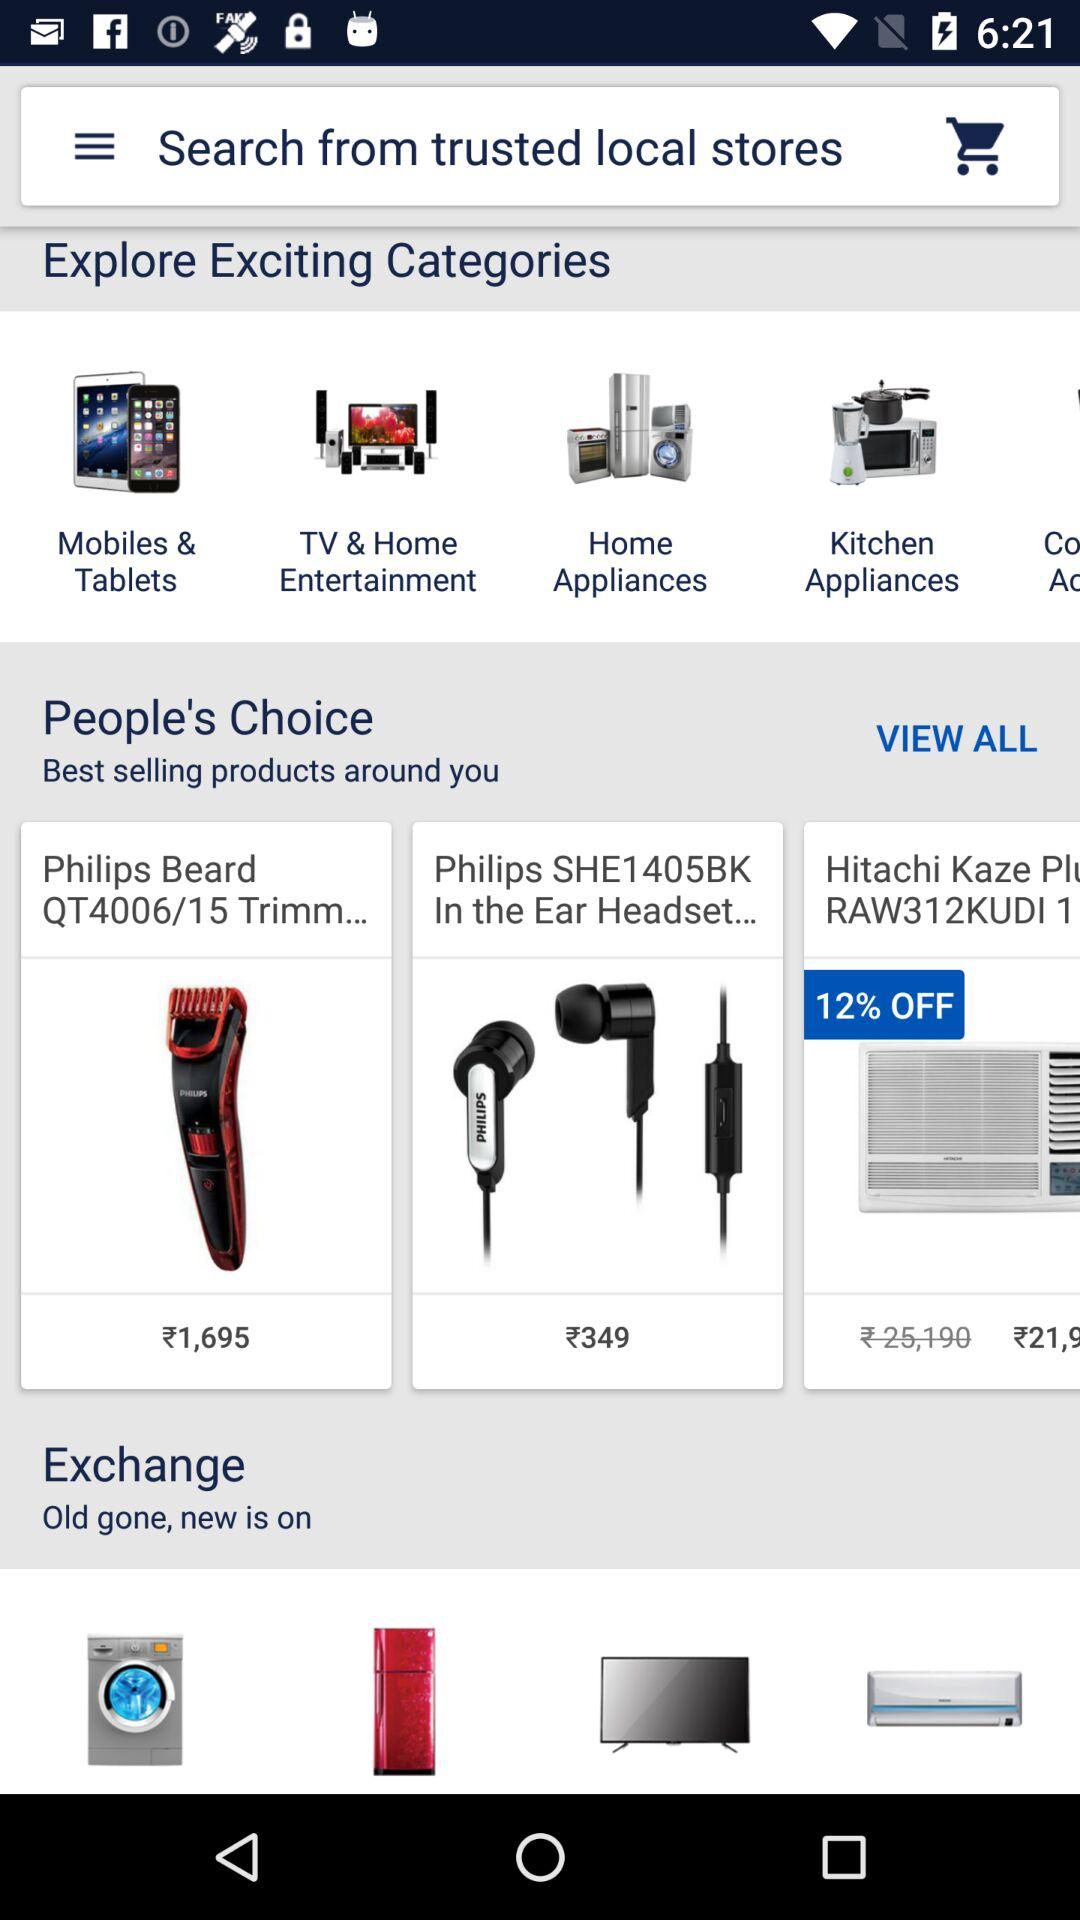What is the price of "Philips beard trimmer"? The price is ₹1,695. 